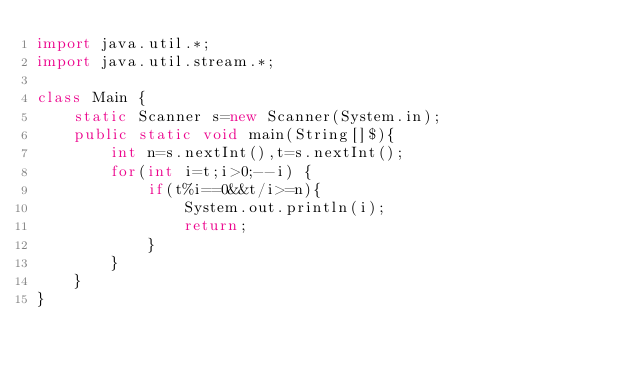<code> <loc_0><loc_0><loc_500><loc_500><_Java_>import java.util.*;
import java.util.stream.*;

class Main {
    static Scanner s=new Scanner(System.in);
    public static void main(String[]$){
        int n=s.nextInt(),t=s.nextInt();
        for(int i=t;i>0;--i) {
            if(t%i==0&&t/i>=n){
                System.out.println(i);
                return;
            }
        }
    }
}
</code> 